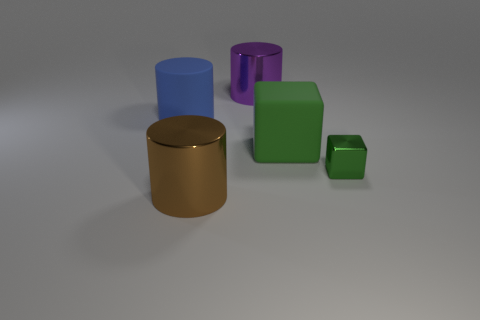Does the large matte object that is in front of the large blue cylinder have the same color as the shiny object that is right of the big purple thing?
Your answer should be compact. Yes. Is the number of green matte things that are behind the green matte thing the same as the number of tiny green blocks?
Keep it short and to the point. No. There is a purple thing; what number of large blue matte cylinders are behind it?
Ensure brevity in your answer.  0. The metal block has what size?
Keep it short and to the point. Small. What color is the thing that is the same material as the blue cylinder?
Your response must be concise. Green. How many purple shiny things are the same size as the green shiny block?
Make the answer very short. 0. Does the large cylinder that is in front of the small thing have the same material as the large block?
Provide a succinct answer. No. Is the number of big blue cylinders that are on the right side of the big purple metallic cylinder less than the number of big blue shiny cylinders?
Offer a very short reply. No. The large object in front of the metal cube has what shape?
Offer a very short reply. Cylinder. The blue object that is the same size as the purple metallic cylinder is what shape?
Your response must be concise. Cylinder. 